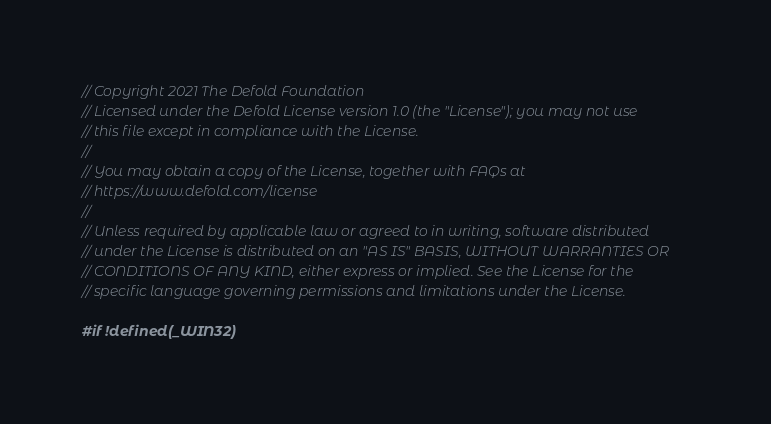<code> <loc_0><loc_0><loc_500><loc_500><_C++_>// Copyright 2021 The Defold Foundation
// Licensed under the Defold License version 1.0 (the "License"); you may not use
// this file except in compliance with the License.
//
// You may obtain a copy of the License, together with FAQs at
// https://www.defold.com/license
//
// Unless required by applicable law or agreed to in writing, software distributed
// under the License is distributed on an "AS IS" BASIS, WITHOUT WARRANTIES OR
// CONDITIONS OF ANY KIND, either express or implied. See the License for the
// specific language governing permissions and limitations under the License.

#if !defined(_WIN32)
</code> 